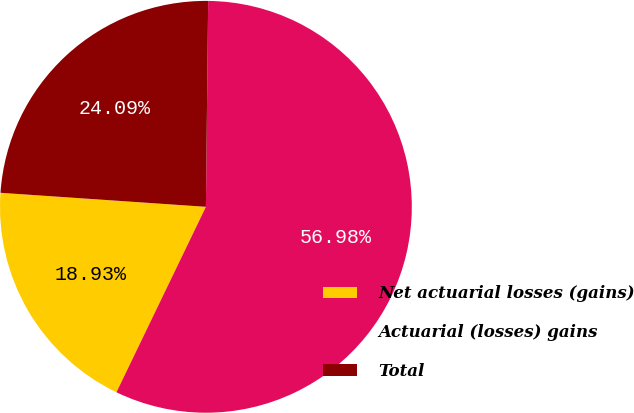<chart> <loc_0><loc_0><loc_500><loc_500><pie_chart><fcel>Net actuarial losses (gains)<fcel>Actuarial (losses) gains<fcel>Total<nl><fcel>18.93%<fcel>56.98%<fcel>24.09%<nl></chart> 